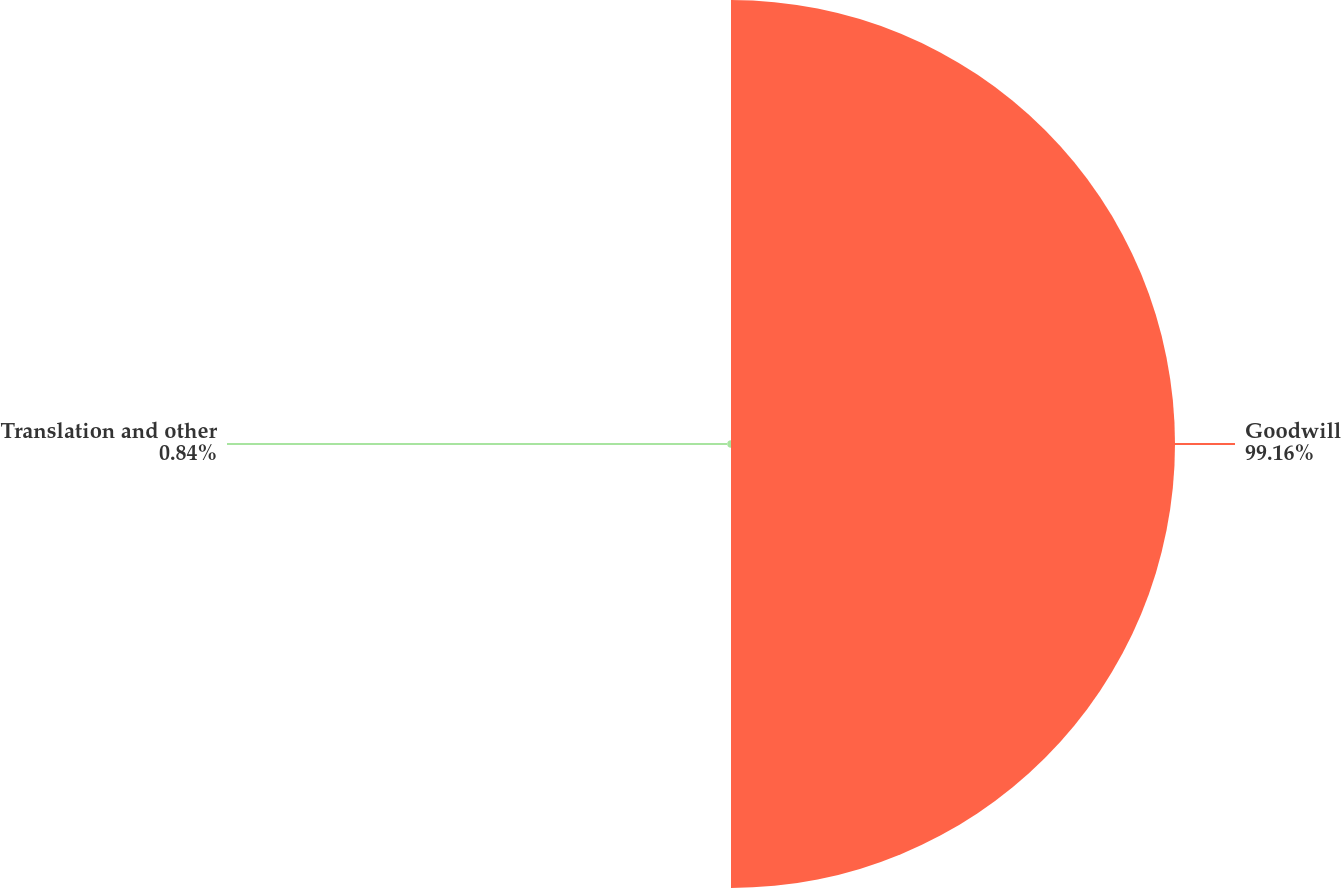Convert chart to OTSL. <chart><loc_0><loc_0><loc_500><loc_500><pie_chart><fcel>Goodwill<fcel>Translation and other<nl><fcel>99.16%<fcel>0.84%<nl></chart> 